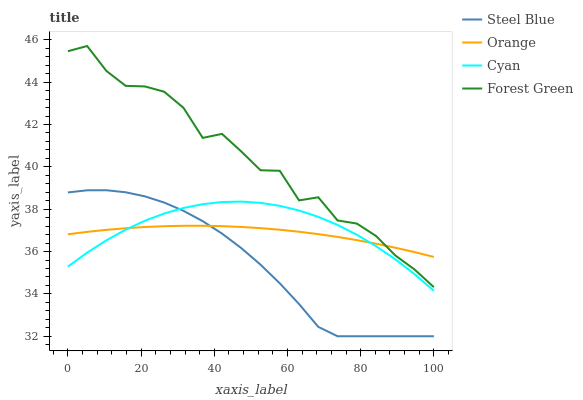Does Cyan have the minimum area under the curve?
Answer yes or no. No. Does Cyan have the maximum area under the curve?
Answer yes or no. No. Is Cyan the smoothest?
Answer yes or no. No. Is Cyan the roughest?
Answer yes or no. No. Does Cyan have the lowest value?
Answer yes or no. No. Does Cyan have the highest value?
Answer yes or no. No. Is Cyan less than Forest Green?
Answer yes or no. Yes. Is Forest Green greater than Cyan?
Answer yes or no. Yes. Does Cyan intersect Forest Green?
Answer yes or no. No. 